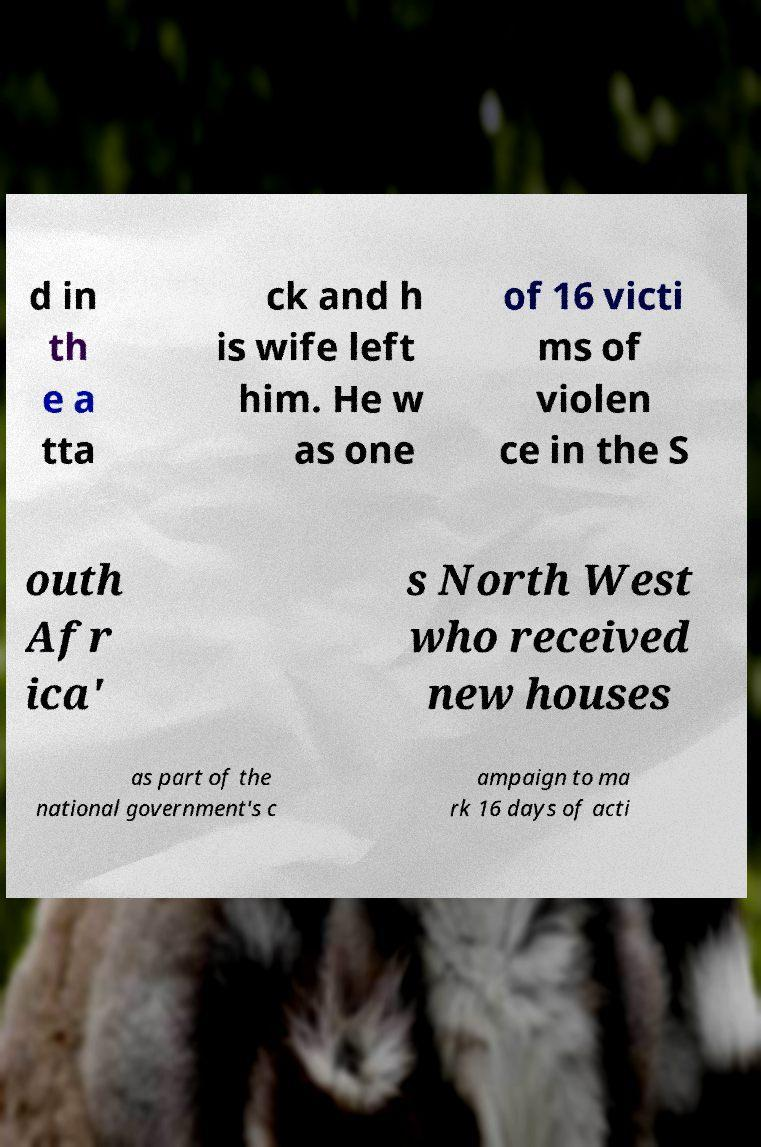Please read and relay the text visible in this image. What does it say? d in th e a tta ck and h is wife left him. He w as one of 16 victi ms of violen ce in the S outh Afr ica' s North West who received new houses as part of the national government's c ampaign to ma rk 16 days of acti 